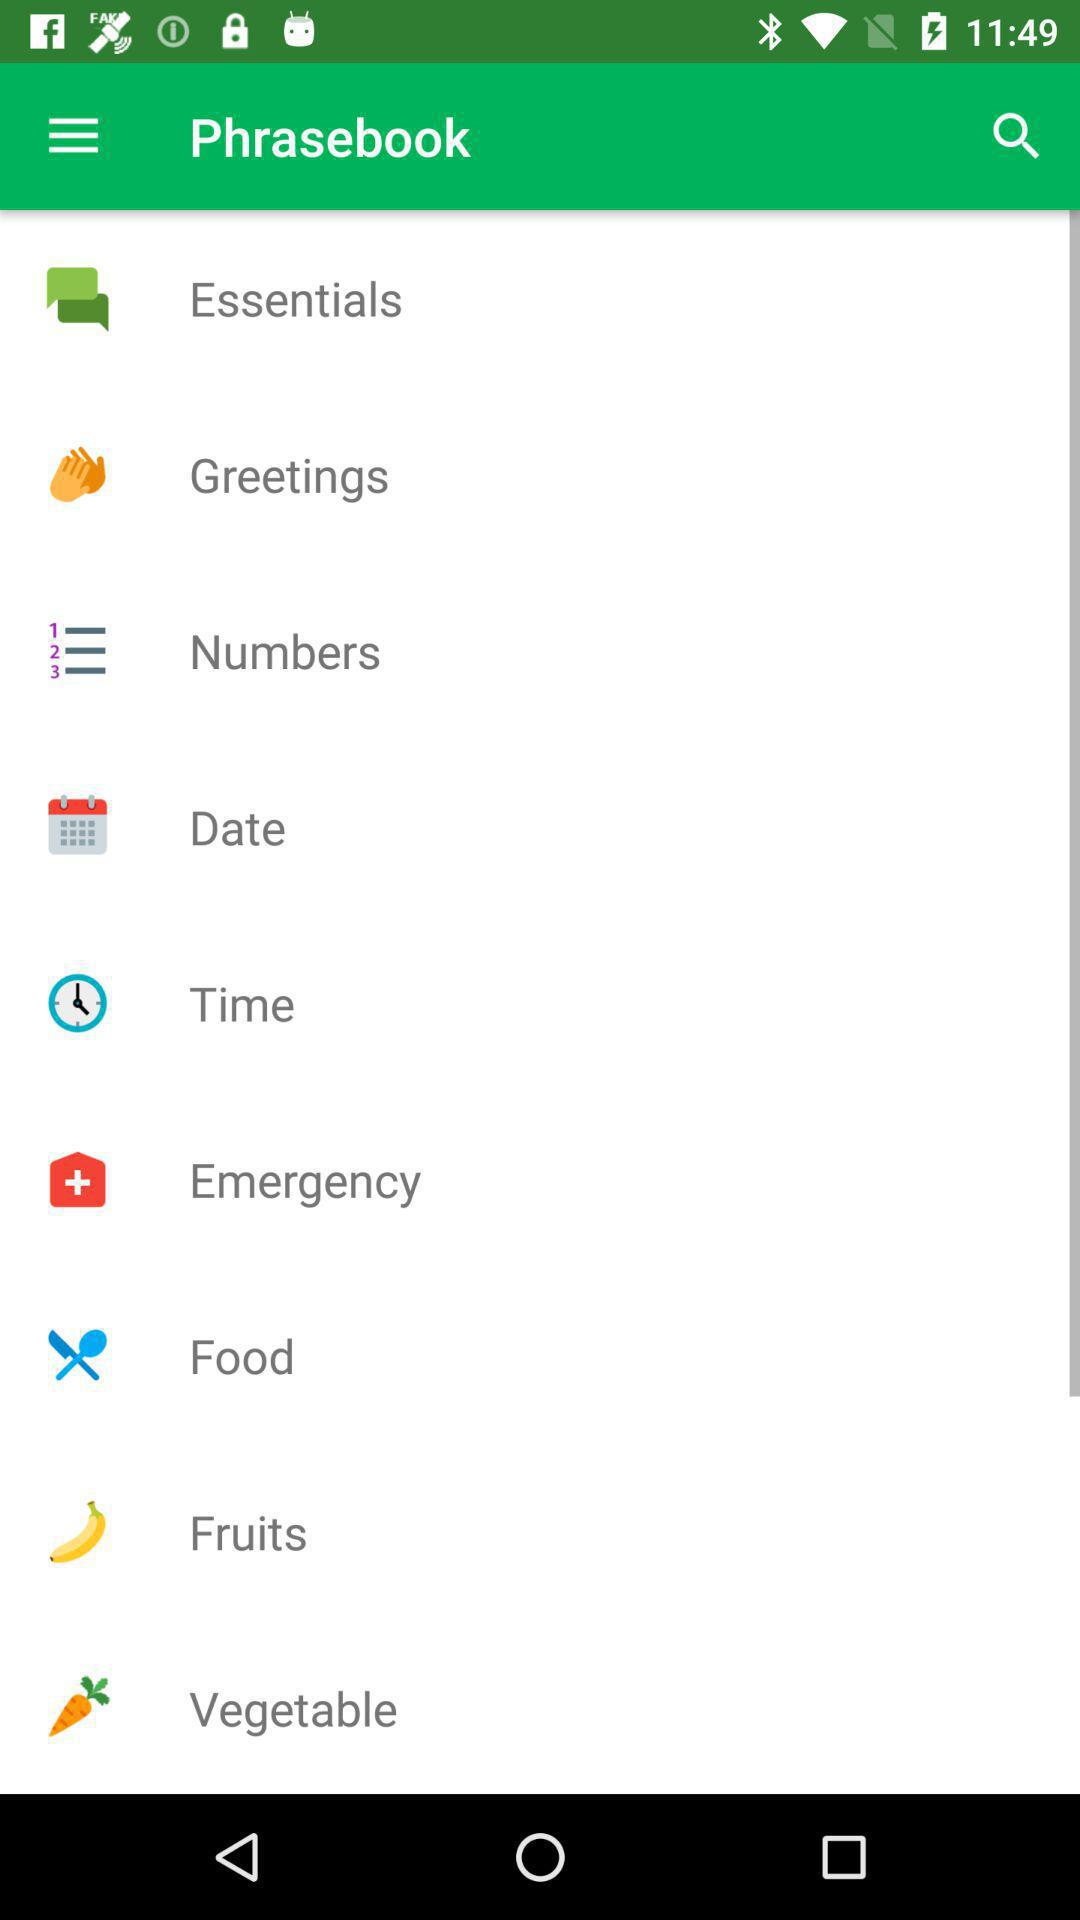What are the available options in "Phrasebook"? The available options are "Essentials", "Greetings", "Numbers", "Date", "Time", "Emergency", "Food", "Fruits" and "Vegetable". 